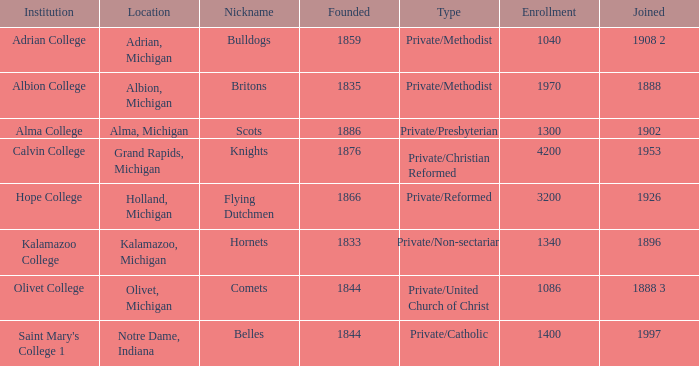Which categories fit under the institution calvin college? Private/Christian Reformed. 